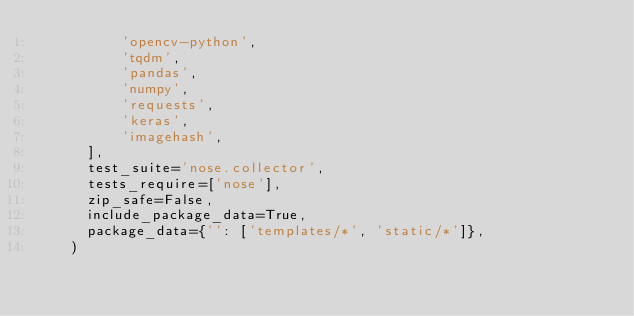<code> <loc_0><loc_0><loc_500><loc_500><_Python_>          'opencv-python',
          'tqdm',
          'pandas',
          'numpy',
          'requests',
          'keras',
          'imagehash',
      ],
      test_suite='nose.collector',
      tests_require=['nose'],
      zip_safe=False,
      include_package_data=True,
      package_data={'': ['templates/*', 'static/*']},
    )
</code> 